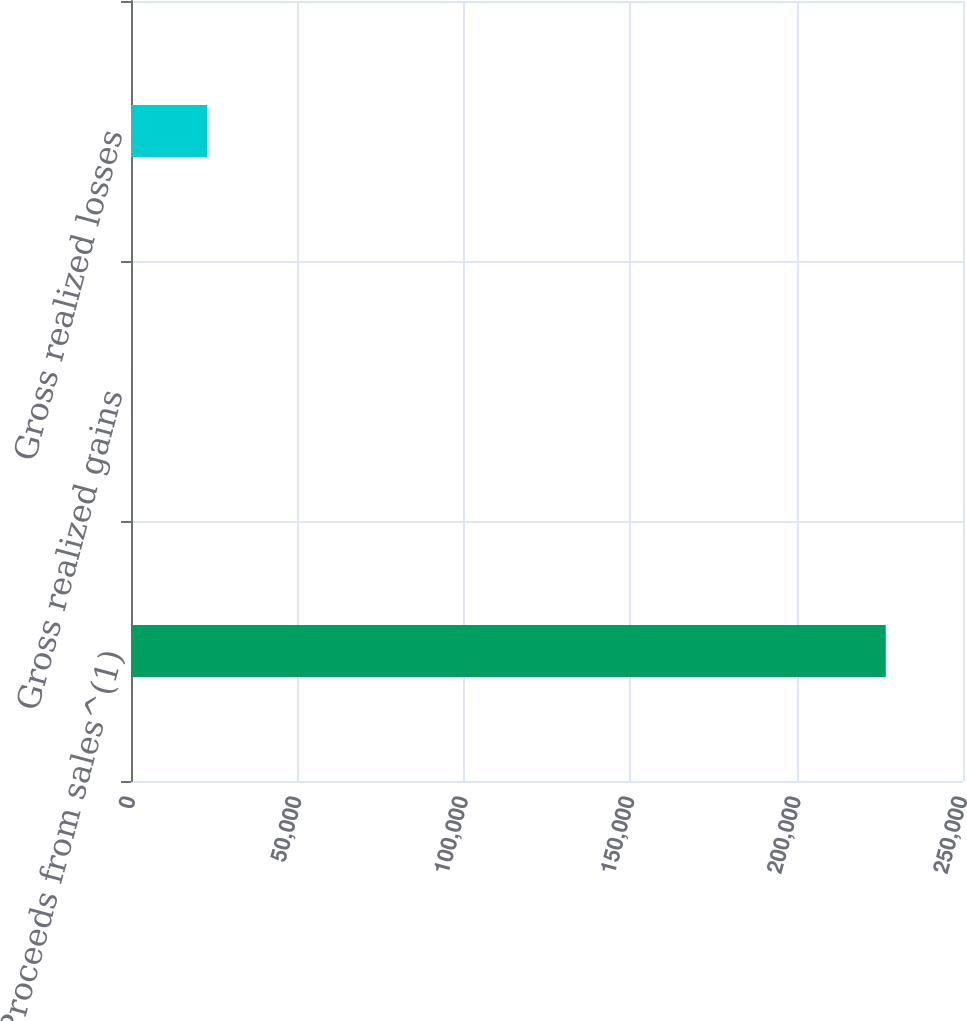<chart> <loc_0><loc_0><loc_500><loc_500><bar_chart><fcel>Proceeds from sales^(1)<fcel>Gross realized gains<fcel>Gross realized losses<nl><fcel>226792<fcel>259<fcel>22912.3<nl></chart> 